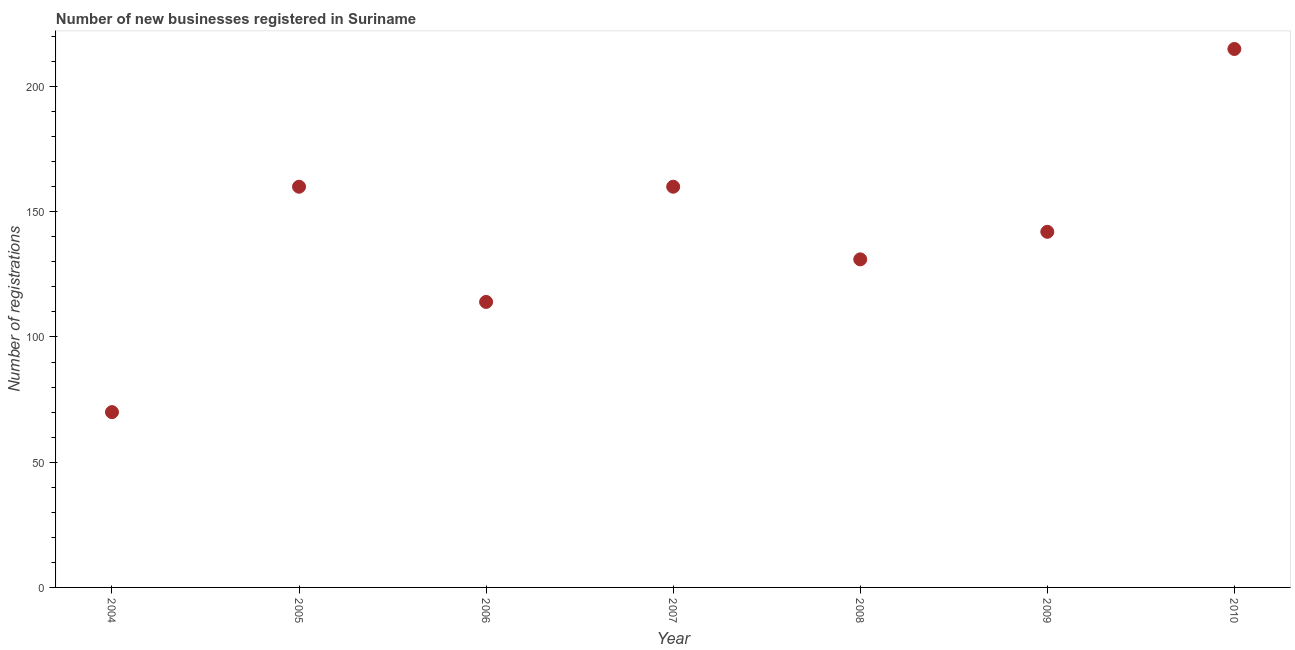What is the number of new business registrations in 2005?
Your answer should be compact. 160. Across all years, what is the maximum number of new business registrations?
Offer a terse response. 215. Across all years, what is the minimum number of new business registrations?
Make the answer very short. 70. In which year was the number of new business registrations maximum?
Offer a very short reply. 2010. In which year was the number of new business registrations minimum?
Keep it short and to the point. 2004. What is the sum of the number of new business registrations?
Provide a short and direct response. 992. What is the difference between the number of new business registrations in 2007 and 2008?
Offer a very short reply. 29. What is the average number of new business registrations per year?
Offer a terse response. 141.71. What is the median number of new business registrations?
Keep it short and to the point. 142. Do a majority of the years between 2009 and 2008 (inclusive) have number of new business registrations greater than 80 ?
Keep it short and to the point. No. What is the ratio of the number of new business registrations in 2004 to that in 2006?
Offer a very short reply. 0.61. What is the difference between the highest and the second highest number of new business registrations?
Your answer should be compact. 55. What is the difference between the highest and the lowest number of new business registrations?
Make the answer very short. 145. In how many years, is the number of new business registrations greater than the average number of new business registrations taken over all years?
Offer a very short reply. 4. How many dotlines are there?
Keep it short and to the point. 1. How many years are there in the graph?
Your answer should be very brief. 7. Are the values on the major ticks of Y-axis written in scientific E-notation?
Offer a terse response. No. What is the title of the graph?
Provide a short and direct response. Number of new businesses registered in Suriname. What is the label or title of the X-axis?
Your response must be concise. Year. What is the label or title of the Y-axis?
Offer a terse response. Number of registrations. What is the Number of registrations in 2004?
Make the answer very short. 70. What is the Number of registrations in 2005?
Offer a terse response. 160. What is the Number of registrations in 2006?
Your answer should be compact. 114. What is the Number of registrations in 2007?
Your answer should be very brief. 160. What is the Number of registrations in 2008?
Offer a very short reply. 131. What is the Number of registrations in 2009?
Ensure brevity in your answer.  142. What is the Number of registrations in 2010?
Make the answer very short. 215. What is the difference between the Number of registrations in 2004 and 2005?
Provide a short and direct response. -90. What is the difference between the Number of registrations in 2004 and 2006?
Your response must be concise. -44. What is the difference between the Number of registrations in 2004 and 2007?
Keep it short and to the point. -90. What is the difference between the Number of registrations in 2004 and 2008?
Offer a terse response. -61. What is the difference between the Number of registrations in 2004 and 2009?
Give a very brief answer. -72. What is the difference between the Number of registrations in 2004 and 2010?
Give a very brief answer. -145. What is the difference between the Number of registrations in 2005 and 2006?
Ensure brevity in your answer.  46. What is the difference between the Number of registrations in 2005 and 2008?
Keep it short and to the point. 29. What is the difference between the Number of registrations in 2005 and 2009?
Your answer should be very brief. 18. What is the difference between the Number of registrations in 2005 and 2010?
Give a very brief answer. -55. What is the difference between the Number of registrations in 2006 and 2007?
Offer a terse response. -46. What is the difference between the Number of registrations in 2006 and 2008?
Ensure brevity in your answer.  -17. What is the difference between the Number of registrations in 2006 and 2010?
Your answer should be very brief. -101. What is the difference between the Number of registrations in 2007 and 2008?
Your answer should be compact. 29. What is the difference between the Number of registrations in 2007 and 2009?
Your answer should be very brief. 18. What is the difference between the Number of registrations in 2007 and 2010?
Offer a terse response. -55. What is the difference between the Number of registrations in 2008 and 2009?
Keep it short and to the point. -11. What is the difference between the Number of registrations in 2008 and 2010?
Your answer should be compact. -84. What is the difference between the Number of registrations in 2009 and 2010?
Ensure brevity in your answer.  -73. What is the ratio of the Number of registrations in 2004 to that in 2005?
Your response must be concise. 0.44. What is the ratio of the Number of registrations in 2004 to that in 2006?
Offer a very short reply. 0.61. What is the ratio of the Number of registrations in 2004 to that in 2007?
Offer a very short reply. 0.44. What is the ratio of the Number of registrations in 2004 to that in 2008?
Give a very brief answer. 0.53. What is the ratio of the Number of registrations in 2004 to that in 2009?
Your answer should be very brief. 0.49. What is the ratio of the Number of registrations in 2004 to that in 2010?
Your answer should be compact. 0.33. What is the ratio of the Number of registrations in 2005 to that in 2006?
Provide a succinct answer. 1.4. What is the ratio of the Number of registrations in 2005 to that in 2008?
Your answer should be compact. 1.22. What is the ratio of the Number of registrations in 2005 to that in 2009?
Offer a very short reply. 1.13. What is the ratio of the Number of registrations in 2005 to that in 2010?
Provide a short and direct response. 0.74. What is the ratio of the Number of registrations in 2006 to that in 2007?
Your answer should be very brief. 0.71. What is the ratio of the Number of registrations in 2006 to that in 2008?
Keep it short and to the point. 0.87. What is the ratio of the Number of registrations in 2006 to that in 2009?
Your response must be concise. 0.8. What is the ratio of the Number of registrations in 2006 to that in 2010?
Your response must be concise. 0.53. What is the ratio of the Number of registrations in 2007 to that in 2008?
Offer a very short reply. 1.22. What is the ratio of the Number of registrations in 2007 to that in 2009?
Your answer should be compact. 1.13. What is the ratio of the Number of registrations in 2007 to that in 2010?
Your answer should be very brief. 0.74. What is the ratio of the Number of registrations in 2008 to that in 2009?
Your answer should be compact. 0.92. What is the ratio of the Number of registrations in 2008 to that in 2010?
Offer a very short reply. 0.61. What is the ratio of the Number of registrations in 2009 to that in 2010?
Offer a terse response. 0.66. 